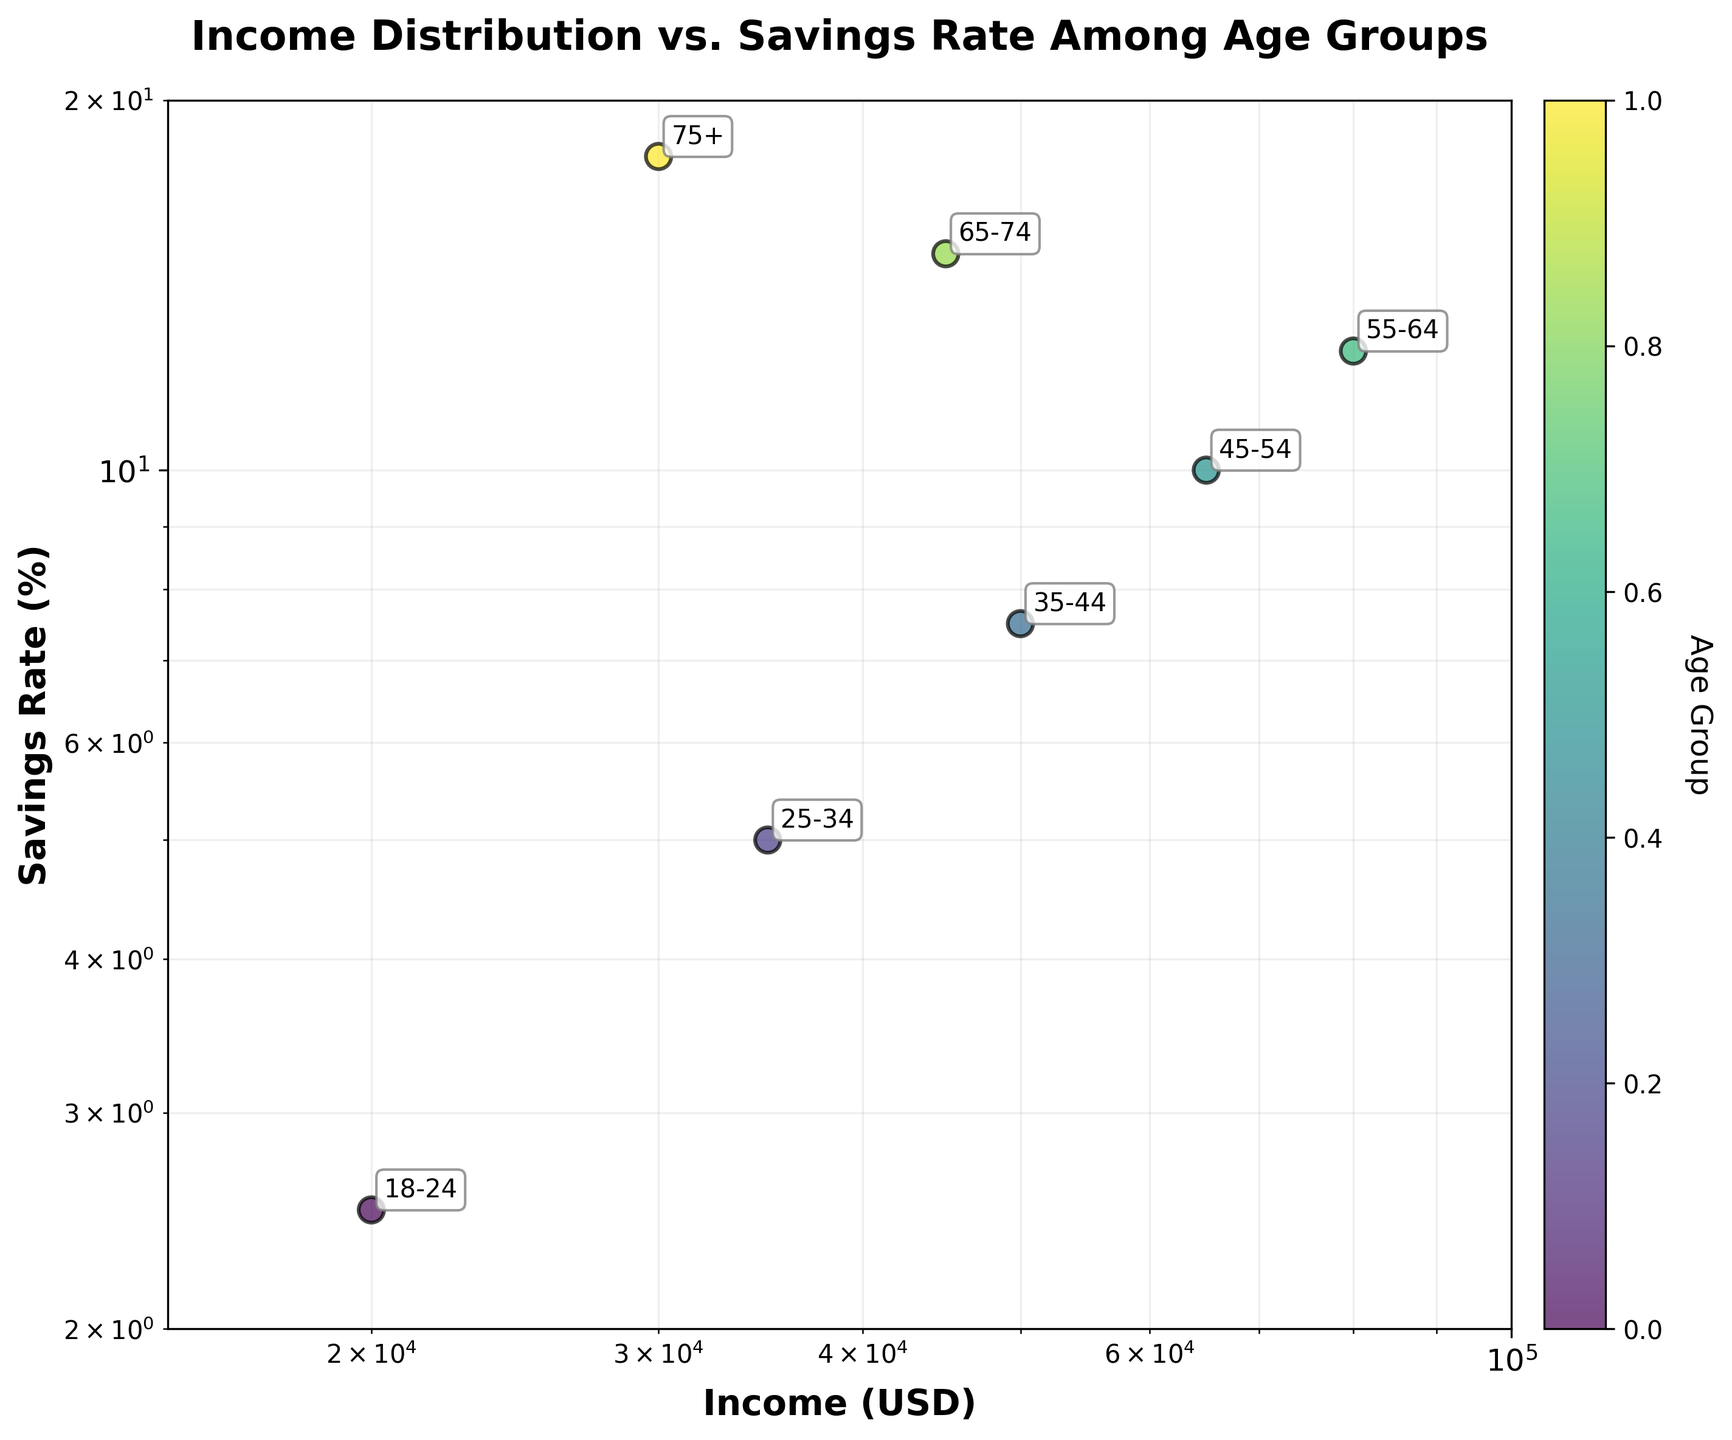what is the title of the plot? The title is displayed prominently above the plot. It reads 'Income Distribution vs. Savings Rate Among Age Groups'.
Answer: Income Distribution vs. Savings Rate Among Age Groups Which age group has the highest savings rate? The highest savings rate is indicated by the point with the highest value on the y-axis. The label '75+' next to this point confirms the age group.
Answer: 75+ What's the relationship between income and savings rate for the 35-44 age group? The savings rate for the 35-44 age group is obtained by locating the point labeled '35-44' and noting its position. The income is around 50,000 USD, and the savings rate is 7.5%.
Answer: 50,000 USD income, 7.5% savings rate What is the x and y-axis of the plot? The x-axis is labeled 'Income (USD)' and the y-axis is labeled 'Savings Rate (%)'.
Answer: Income (USD), Savings Rate (%) Between which age groups is the savings rate difference the greatest? By observing the y-axis positions of the points, the largest difference is between the 75+ group at 18% and the 18-24 group at 2.5%.
Answer: 75+ and 18-24 Which age group has the least income? The point with the smallest value on the x-axis represents the lowest income. The label '18-24' confirms this age group.
Answer: 18-24 By what factor does the income increase from the 18-24 age group to the 55-64 age group? Both axes are on a log scale. To find the factor, divide the income for 55-64 (80,000 USD) by the income for 18-24 (20,000 USD), resulting in a factor of 4.
Answer: 4 Is there a trend between the income levels and savings rates as age increases? Observing the plot, there is a trend of increasing savings rates with increasing age until 65-74, where income decreases but savings rates increase.
Answer: Increasing with deviations Which age groups have a savings rate above 10%? Points above the 10% mark on the y-axis represent these age groups. The labels show 55-64, 65-74, and 75+.
Answer: 55-64, 65-74, 75+ How much higher is the savings rate of the 75+ group compared to the 45-54 group? The 75+ group has a savings rate of 18% and the 45-54 group has a savings rate of 10%. The difference is 18% - 10% = 8%.
Answer: 8% 